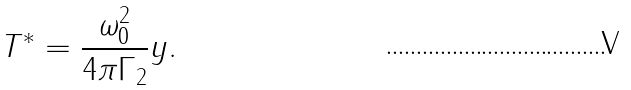<formula> <loc_0><loc_0><loc_500><loc_500>T ^ { * } = \frac { \omega _ { 0 } ^ { 2 } } { 4 \pi \Gamma _ { 2 } } y .</formula> 